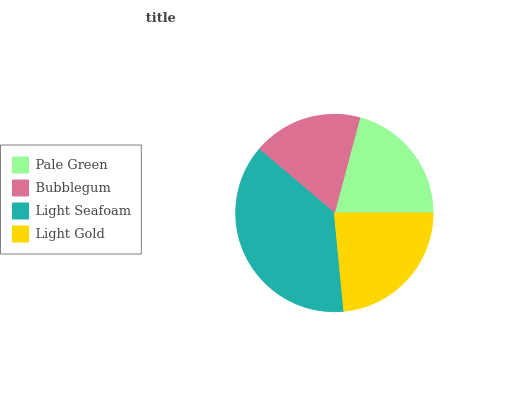Is Bubblegum the minimum?
Answer yes or no. Yes. Is Light Seafoam the maximum?
Answer yes or no. Yes. Is Light Seafoam the minimum?
Answer yes or no. No. Is Bubblegum the maximum?
Answer yes or no. No. Is Light Seafoam greater than Bubblegum?
Answer yes or no. Yes. Is Bubblegum less than Light Seafoam?
Answer yes or no. Yes. Is Bubblegum greater than Light Seafoam?
Answer yes or no. No. Is Light Seafoam less than Bubblegum?
Answer yes or no. No. Is Light Gold the high median?
Answer yes or no. Yes. Is Pale Green the low median?
Answer yes or no. Yes. Is Pale Green the high median?
Answer yes or no. No. Is Light Seafoam the low median?
Answer yes or no. No. 